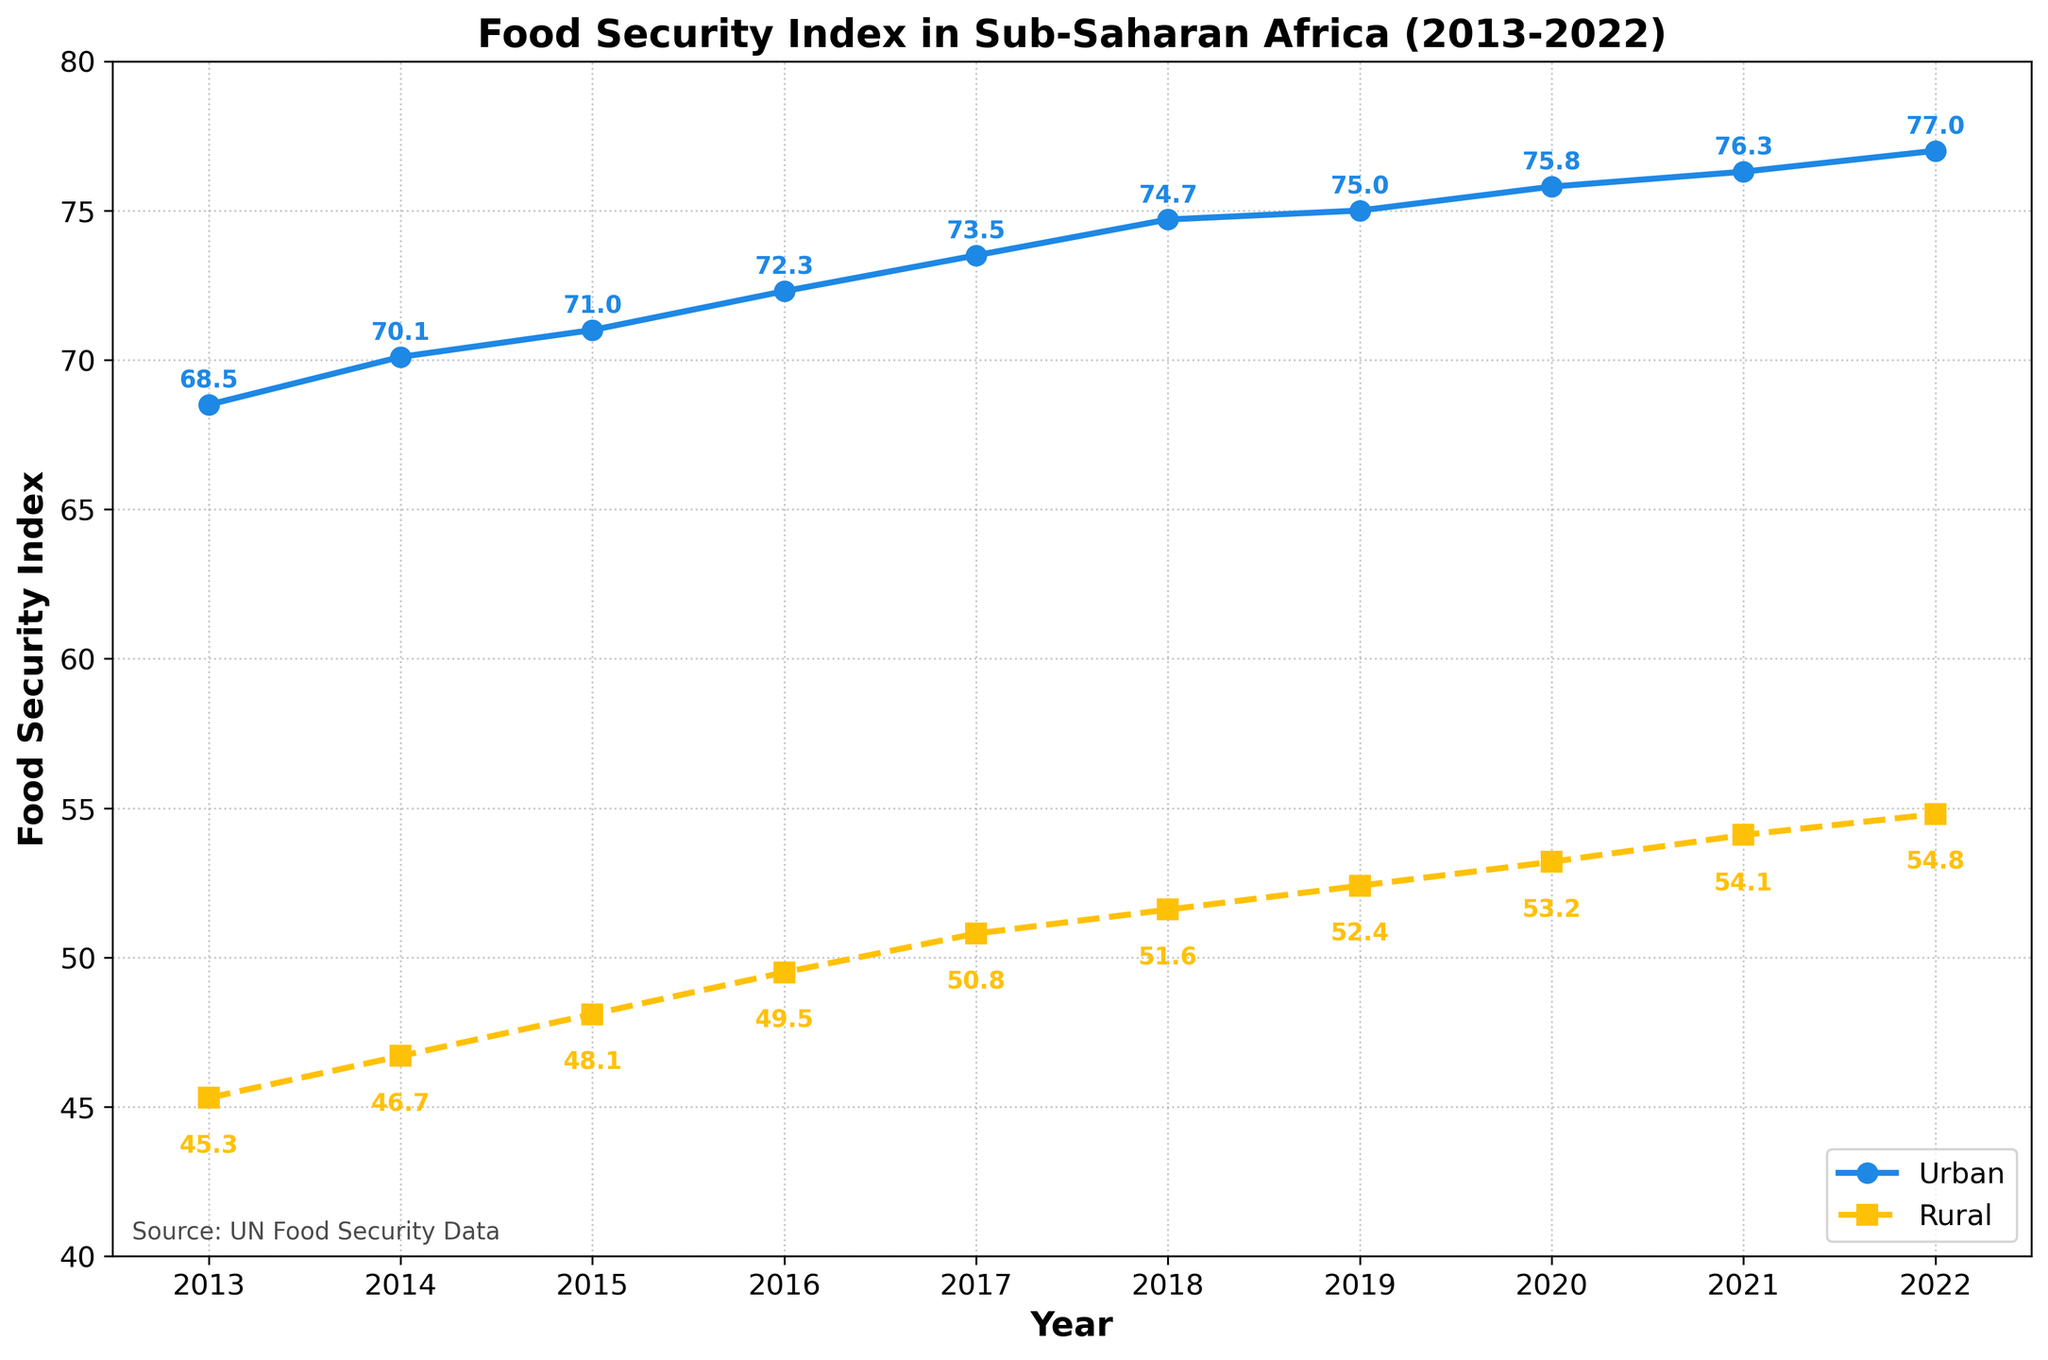What is the title of the plot? The title is displayed in bold at the top of the plot. It summarizes the main focus of the figure.
Answer: Food Security Index in Sub-Saharan Africa (2013-2022) What are the labels of the x and y axes? The axis labels are found on the left side (y-axis) and the bottom (x-axis) of the chart, indicating what each axis represents.
Answer: Year (x-axis) and Food Security Index (y-axis) How did the Food Security Index in rural areas change from 2013 to 2022? Identify the initial value for rural areas in 2013 and the final value in 2022 by looking at the data points and annotations, and compute the difference.
Answer: Increased from 45.3 to 54.8 How does the trend in food security for urban areas compare to rural areas over the last decade? Observe the overall trend lines for both urban and rural areas from 2013 to 2022. Note whether each trend is an increase, decrease, or remains stable. Since both lines are consistently rising, we can state that both trends show improvement, but at different levels and rates.
Answer: Both areas show an increasing trend, but urban areas consistently have higher indices In which year did the urban areas see the most significant increase in the Food Security Index? Calculate the yearly differences for urban values and identify the largest increase by comparing them. The biggest increase occurred from 2018 to 2019 (from 74.7 to 75.0).
Answer: 2018 to 2019 Which year had the smallest gap between Urban and Rural Food Security Index? Subtract the Rural index from the Urban index for each year and find the year with the smallest result. The smallest gap occurred in 2013, with a difference of 23.2 (68.5 - 45.3).
Answer: 2013 By how much did the Food Security Index improve in rural areas between 2015 and 2020? Locate the rural data points for 2015 and 2020, then subtract the 2015 value from the 2020 value. The improvement equals 53.2 - 48.1 = 5.1.
Answer: 5.1 What is the average Food Security Index for urban areas from 2018 to 2020? Add the urban food security indices for the years 2018, 2019, and 2020, then divide by the number of years. (74.7 + 75.0 + 75.8) / 3 = 75.17.
Answer: 75.2 How did the rate of improvement for rural areas compare between the periods 2013-2017 and 2018-2022? Compute the difference over the years for each period: 2017 value minus 2013 value and 2022 value minus 2018 value. For 2013-2017: 50.8 - 45.3 = 5.5. For 2018-2022: 54.8 - 51.6 = 3.2. Compare these two differences.
Answer: Improved more from 2013 to 2017 (5.5) than from 2018 to 2022 (3.2) What was the percentage increase in the Food Security Index for urban areas from 2013 to 2022? Use the formula [(Final - Initial) / Initial] * 100. For 2013 to 2022: [(77.0 - 68.5) / 68.5] * 100 = 12.4%.
Answer: 12.4% 